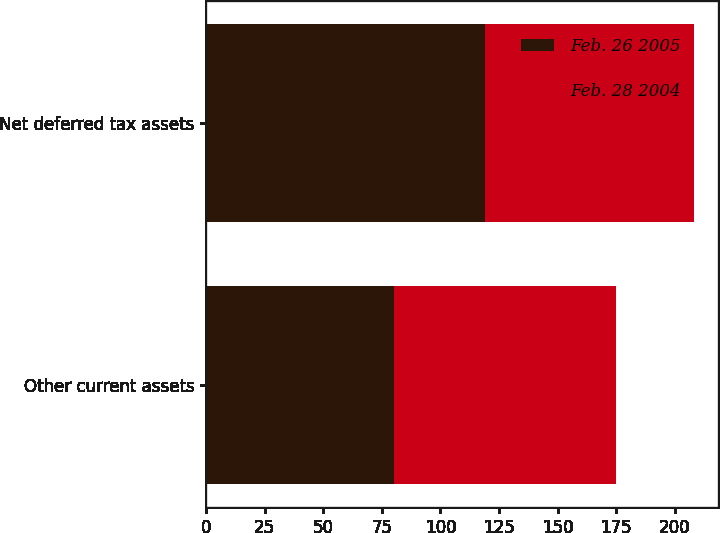Convert chart to OTSL. <chart><loc_0><loc_0><loc_500><loc_500><stacked_bar_chart><ecel><fcel>Other current assets<fcel>Net deferred tax assets<nl><fcel>Feb. 26 2005<fcel>80<fcel>119<nl><fcel>Feb. 28 2004<fcel>95<fcel>89<nl></chart> 